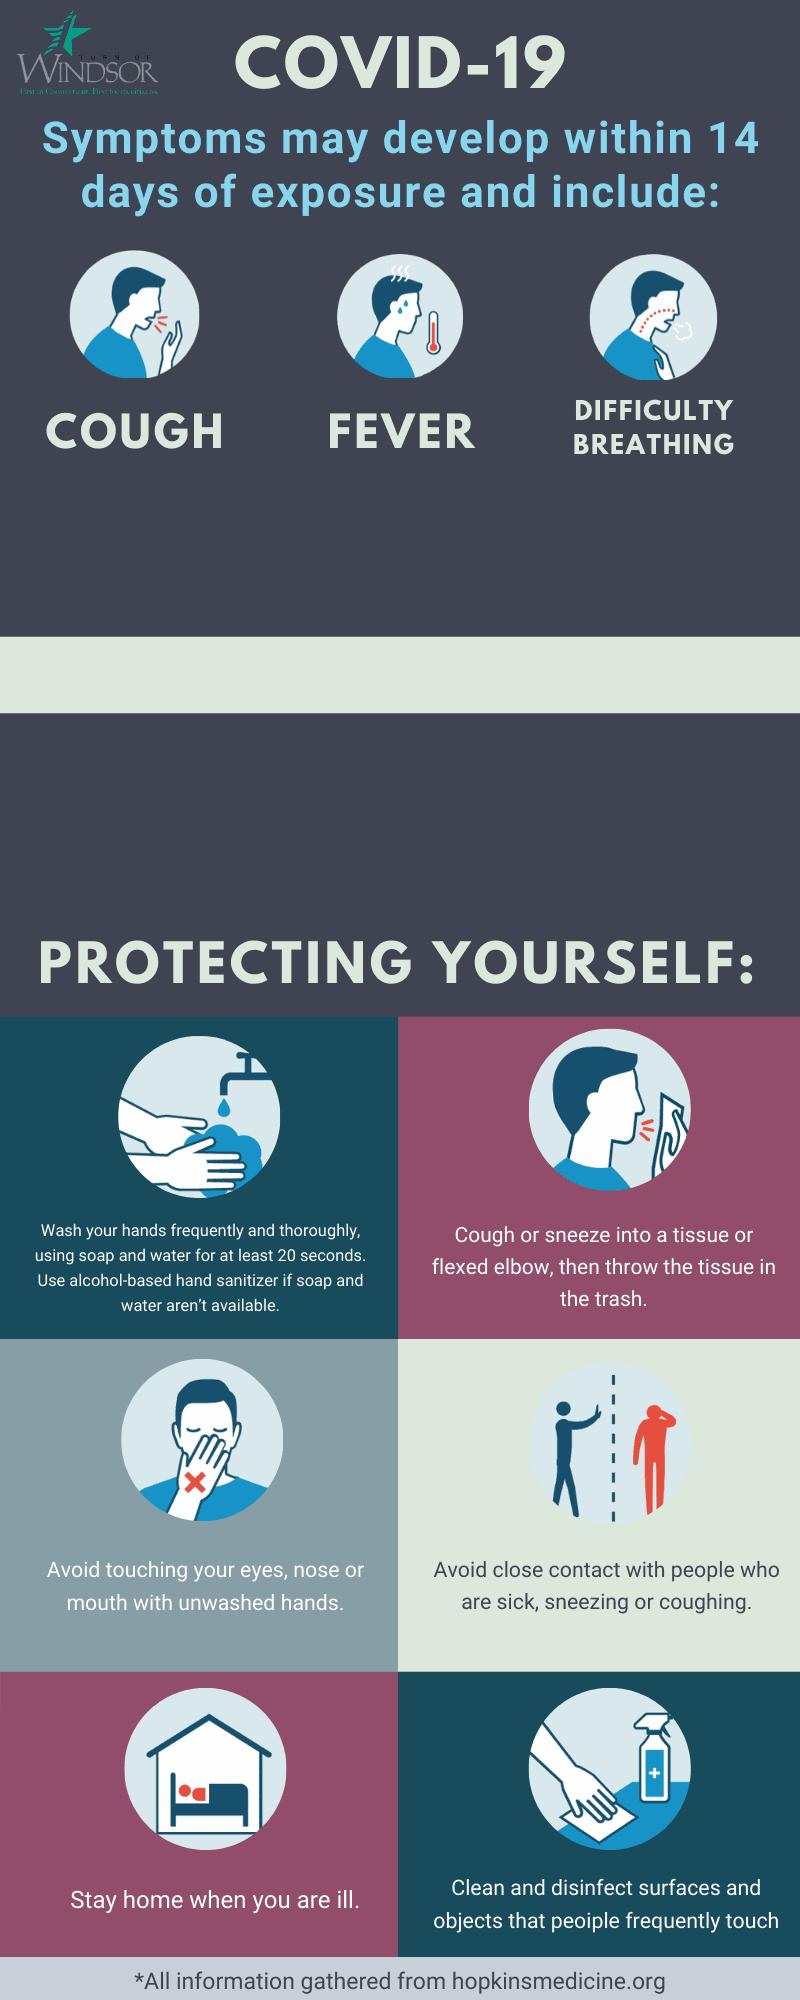Draw attention to some important aspects in this diagram. COVID-19, in addition to causing symptoms such as cough and difficulty breathing, can also present with a fever. It is important to note that fever can be an indicator of COVID-19 infection. The incubation period of COVID-19 is 14 days. 